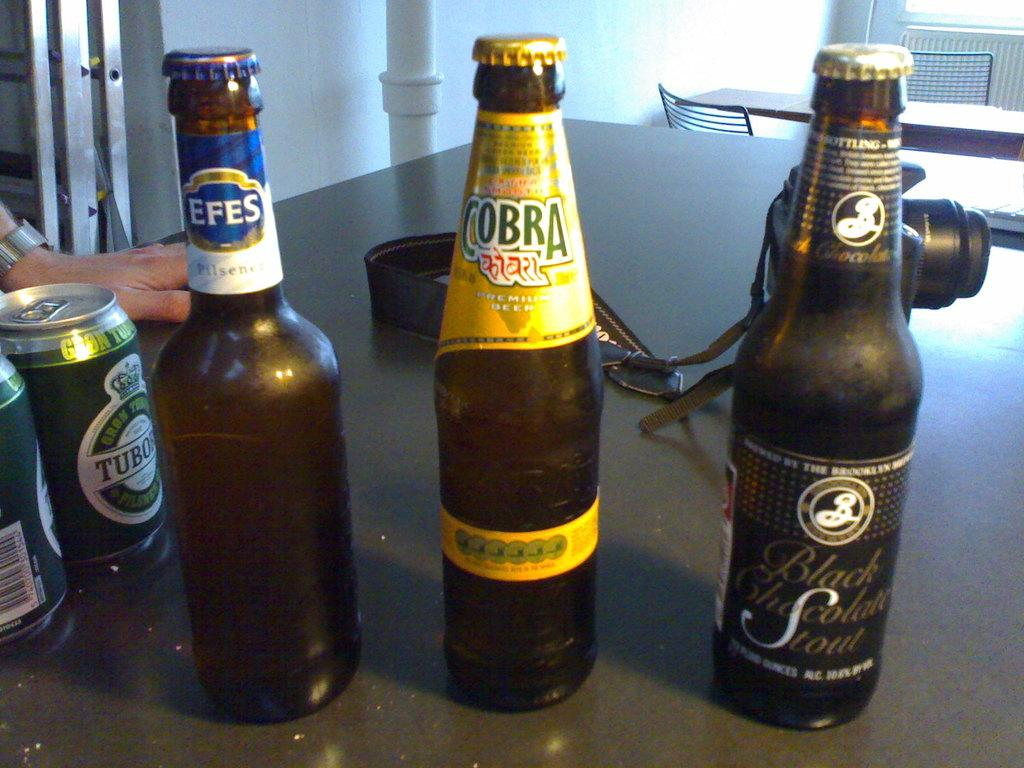<image>
Offer a succinct explanation of the picture presented. A bottle of Cobra beer is on a table with other bottles and cans of beer. 